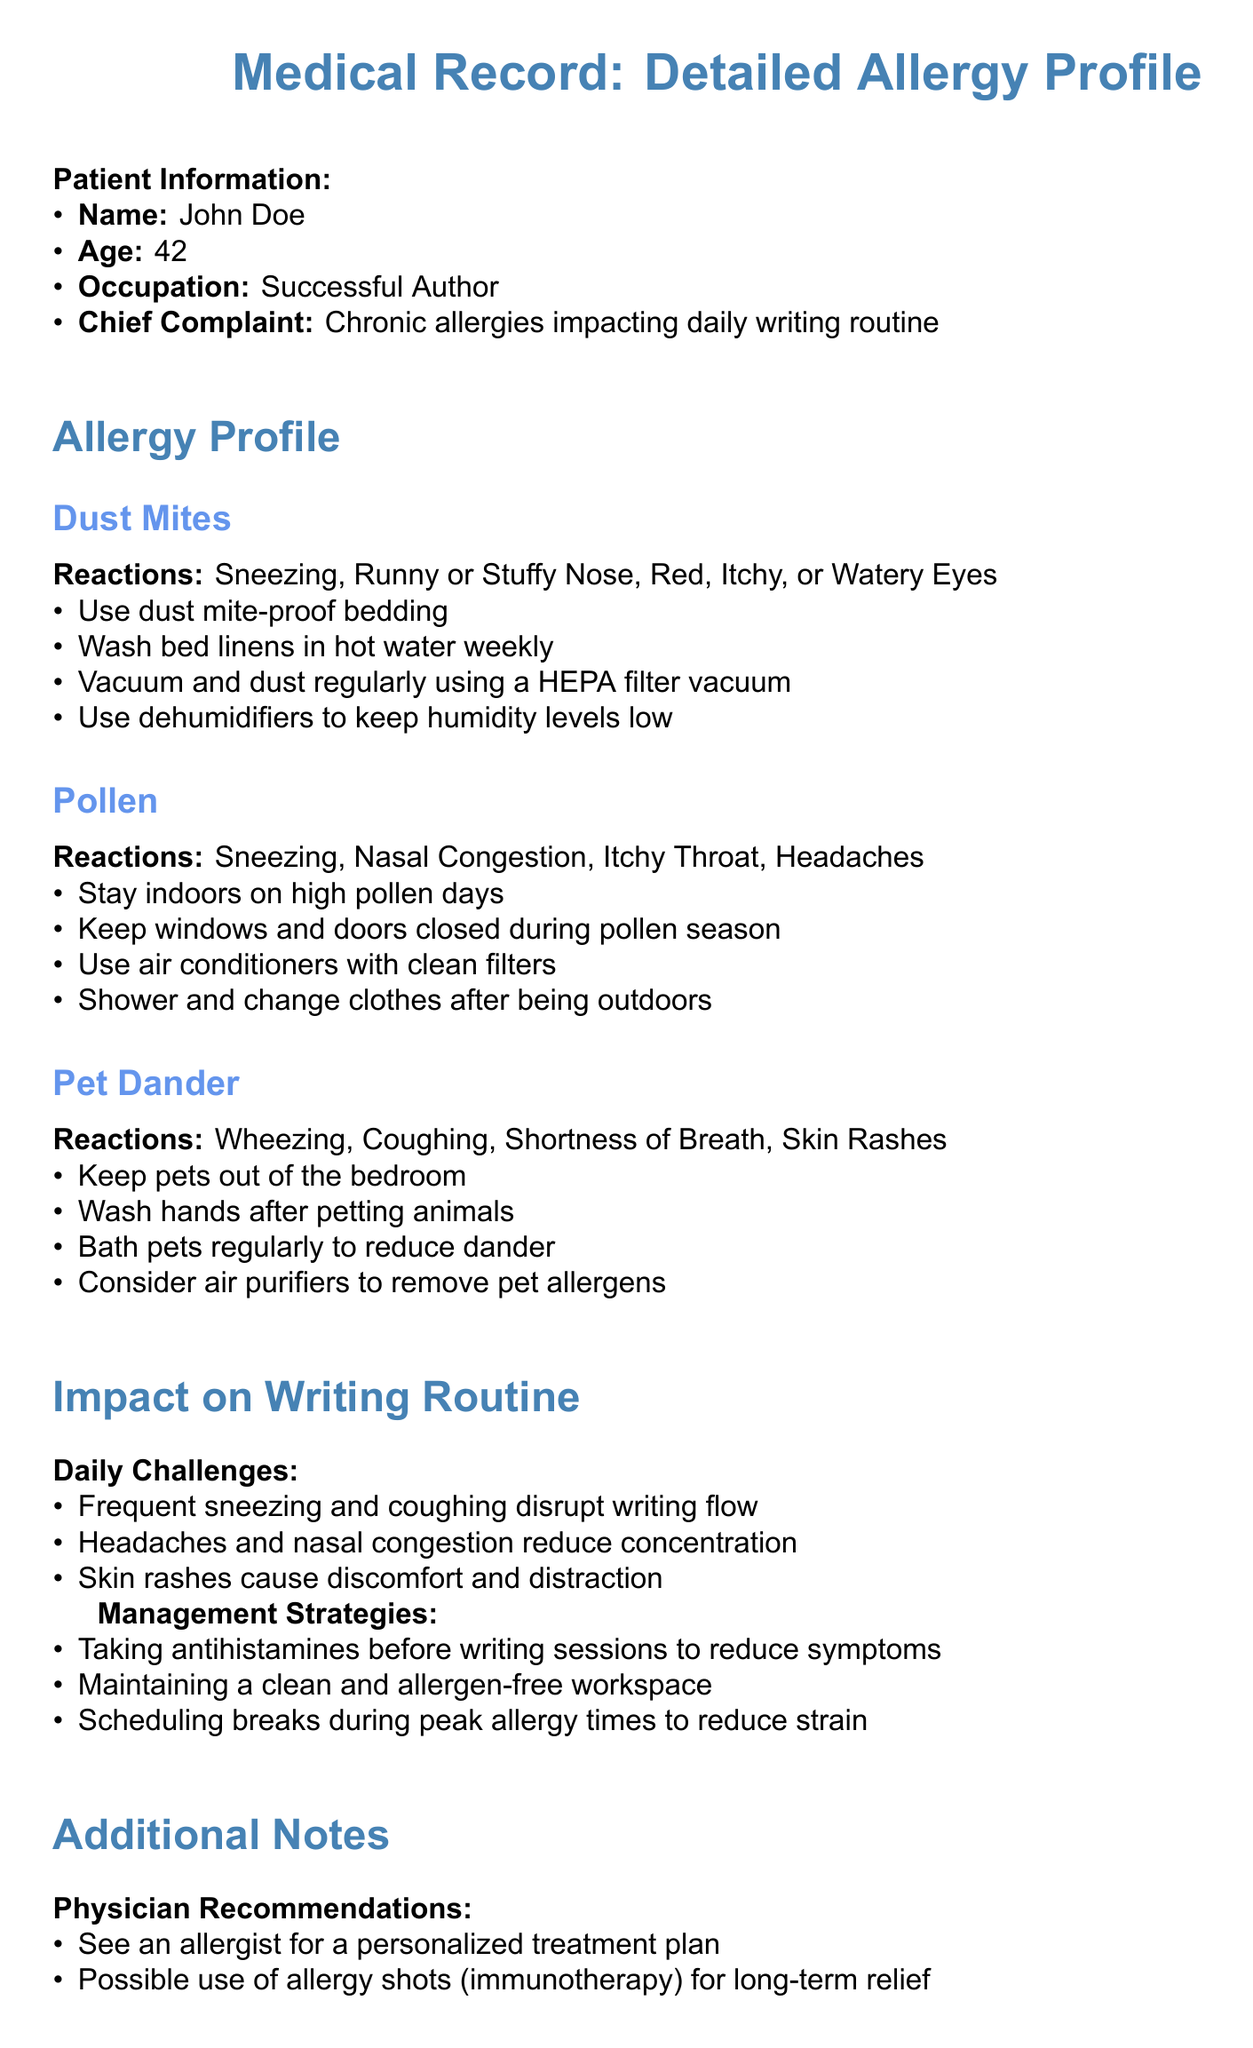What is the patient’s name? The patient's name is mentioned at the beginning of the document under Patient Information.
Answer: John Doe What is the age of the patient? The patient's age is listed directly under Patient Information in the document.
Answer: 42 What is one recommended way to manage dust mite allergies? This can be found in the Dust Mites section, where recommendations for avoiding allergens are provided.
Answer: Use dust mite-proof bedding What reactions does the patient have to pollen? The reactions to pollen are outlined in the Pollen section of the document.
Answer: Sneezing, Nasal Congestion, Itchy Throat, Headaches What is one challenge faced by the patient in their writing routine? The document outlines daily challenges specifically impacting the patient's writing routine.
Answer: Frequent sneezing and coughing disrupt writing flow What is the physician's recommendation for treatment? You can find this in the Additional Notes section related to physician recommendations.
Answer: See an allergist for a personalized treatment plan What is one management strategy to assist with writing during allergy symptoms? This information is contained within the Management Strategies part of the Impact on Writing Routine section.
Answer: Taking antihistamines before writing sessions to reduce symptoms What type of document is this? The document is specifically categorized at the top of the document as a Medical Record.
Answer: Medical Record What is one specific allergy mentioned in the profile? Specific allergies are listed in the Allergy Profile section of the document.
Answer: Dust Mites What could the patient consider using on high-symptom days? The answer is found within the Lifestyle Adjustments section of the document.
Answer: Voice-to-text software 